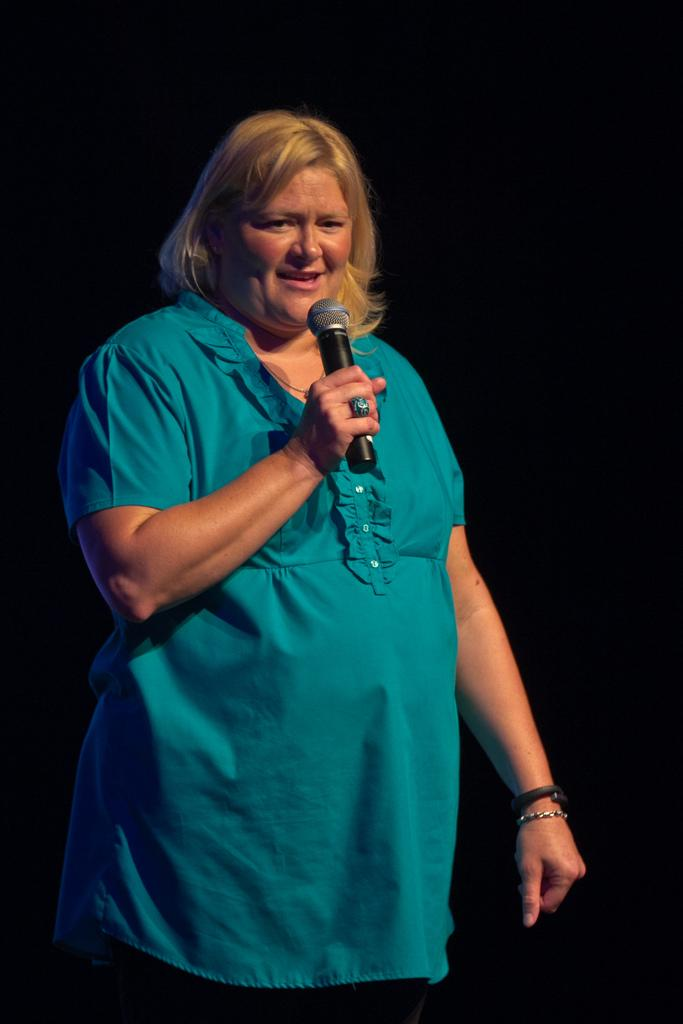Who is the main subject in the image? There is a woman in the image. What is the woman wearing? The woman is wearing a blue top. What is the woman doing in the image? The woman is standing and giving a speech. What is the woman using to amplify her voice? There is a microphone in the image. What arithmetic problem is the woman solving on the notebook in the image? There is no notebook present in the image, and the woman is giving a speech, not solving an arithmetic problem. 